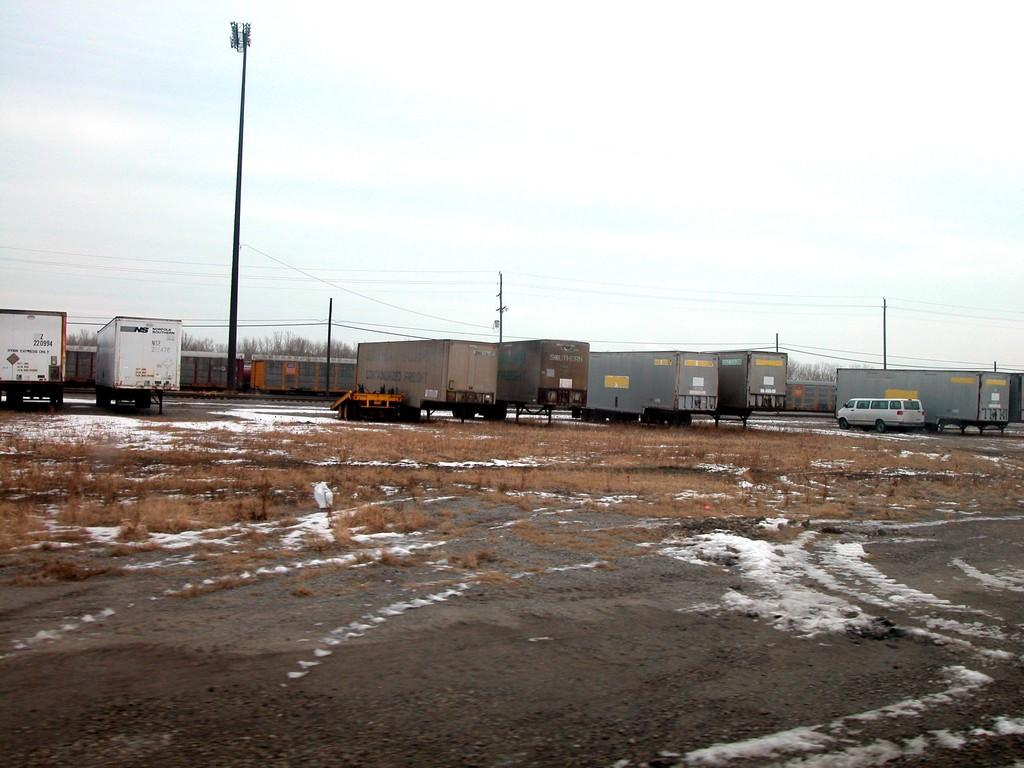What type of vegetation is present on the ground in the center of the image? There is dry grass on the ground in the center of the image. What can be seen in the background of the image? In the background of the image, there are vehicles, poles, trees, and a fence. How would you describe the sky in the image? The sky is cloudy in the image. What type of reward is being given to the butter in the image? There is no butter or reward present in the image. Who is the friend that can be seen in the image? There are no people or friends depicted in the image. 